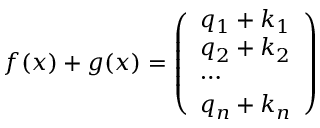<formula> <loc_0><loc_0><loc_500><loc_500>\begin{array} { r } { f ( x ) + g ( x ) = \left ( \begin{array} { l } { q _ { 1 } + k _ { 1 } } \\ { q _ { 2 } + k _ { 2 } } \\ { \cdots } \\ { q _ { n } + k _ { n } } \end{array} \right ) } \end{array}</formula> 